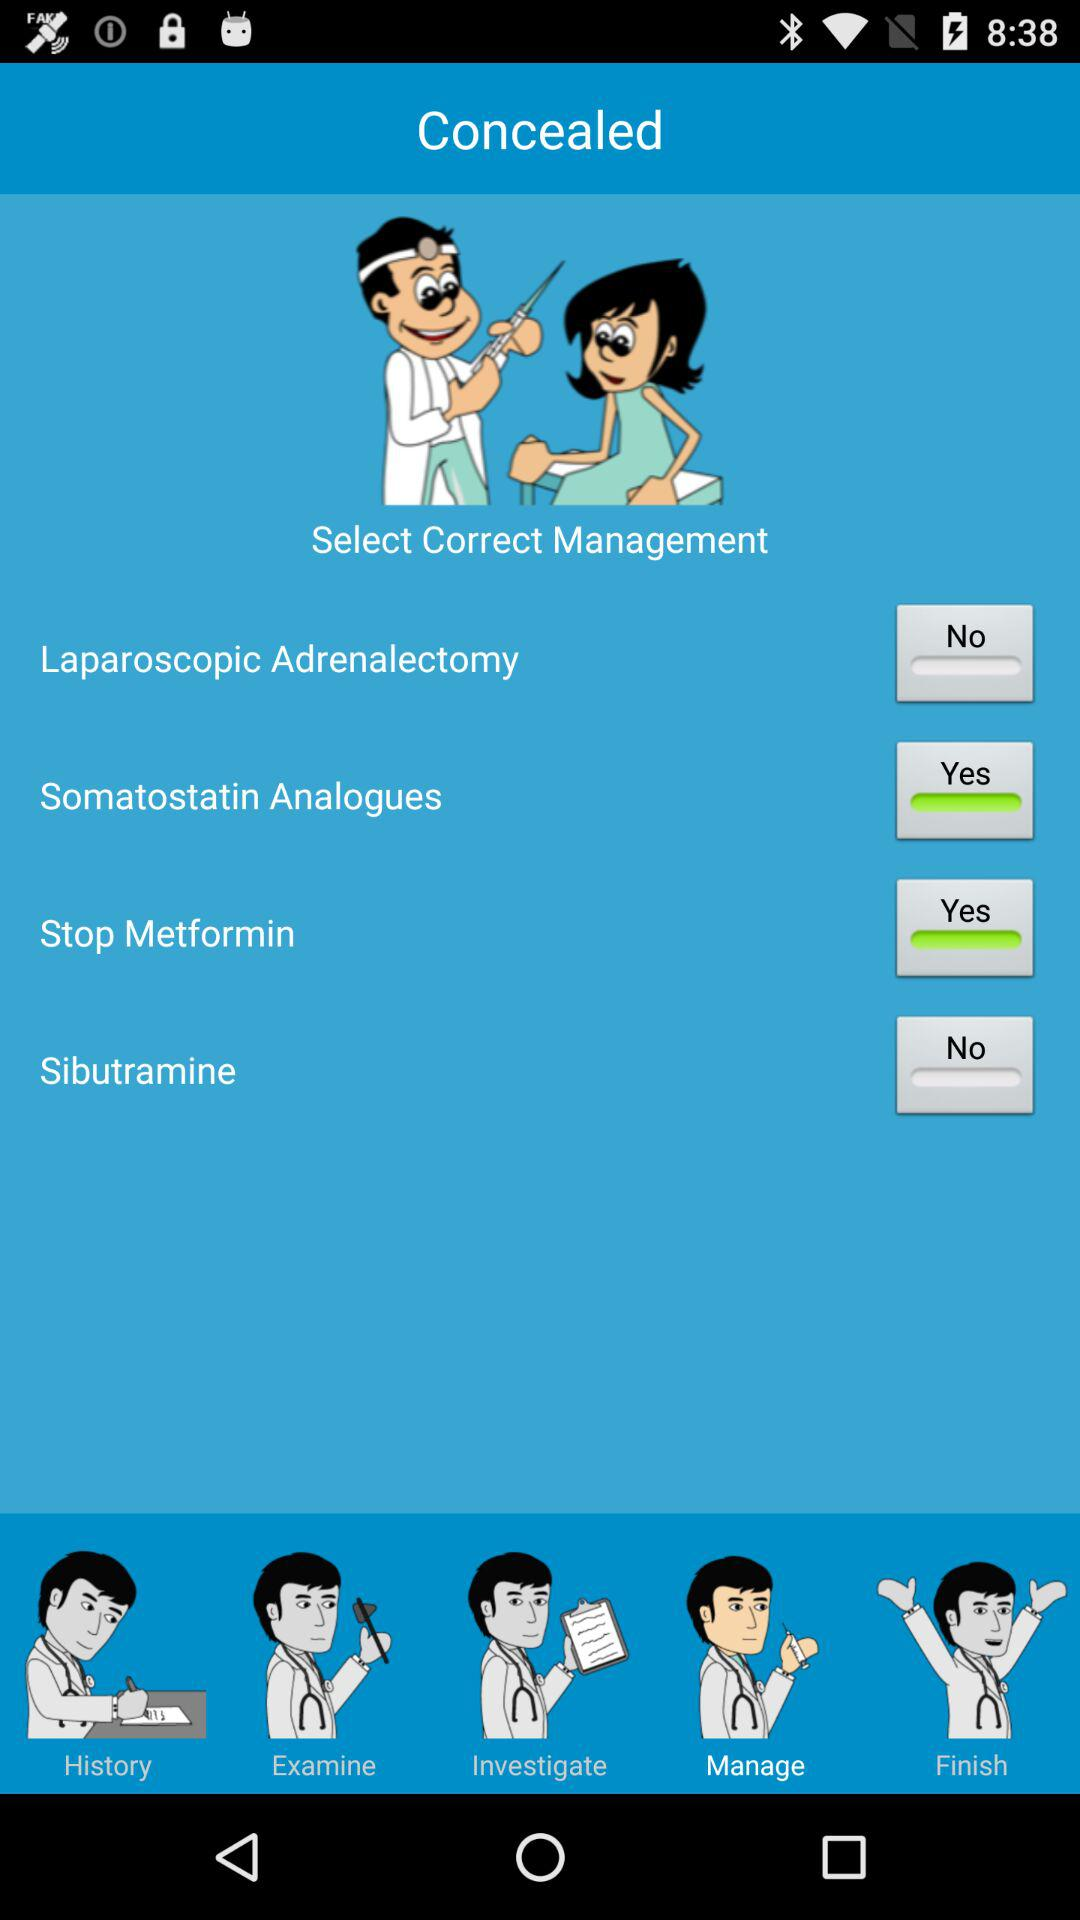On which tab am I now? You are on the "Manage" tab. 